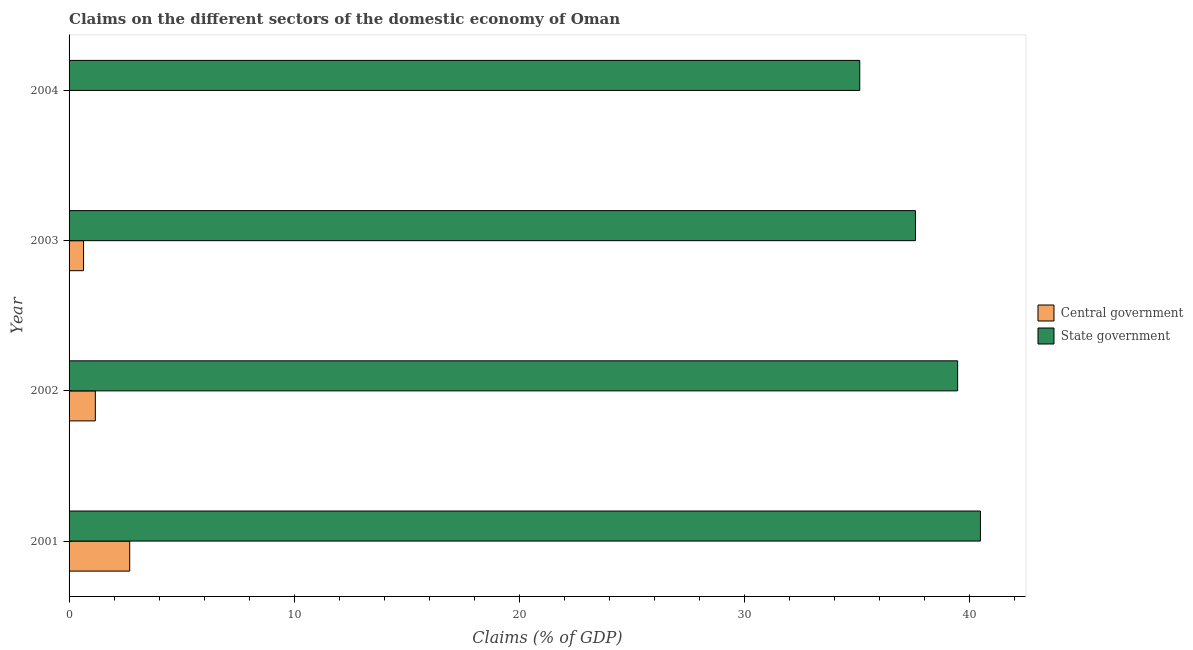How many different coloured bars are there?
Ensure brevity in your answer.  2. How many bars are there on the 2nd tick from the bottom?
Ensure brevity in your answer.  2. What is the label of the 2nd group of bars from the top?
Your answer should be very brief. 2003. In how many cases, is the number of bars for a given year not equal to the number of legend labels?
Your answer should be compact. 1. What is the claims on state government in 2001?
Provide a short and direct response. 40.51. Across all years, what is the maximum claims on state government?
Your answer should be compact. 40.51. Across all years, what is the minimum claims on state government?
Your response must be concise. 35.14. What is the total claims on central government in the graph?
Provide a short and direct response. 4.51. What is the difference between the claims on state government in 2001 and that in 2002?
Make the answer very short. 1.01. What is the difference between the claims on state government in 2002 and the claims on central government in 2001?
Make the answer very short. 36.8. What is the average claims on central government per year?
Your response must be concise. 1.13. In the year 2003, what is the difference between the claims on state government and claims on central government?
Make the answer very short. 36.97. What is the ratio of the claims on state government in 2001 to that in 2003?
Your answer should be compact. 1.08. Is the claims on central government in 2001 less than that in 2003?
Keep it short and to the point. No. What is the difference between the highest and the second highest claims on central government?
Your answer should be compact. 1.53. What is the difference between the highest and the lowest claims on central government?
Offer a terse response. 2.7. In how many years, is the claims on central government greater than the average claims on central government taken over all years?
Give a very brief answer. 2. What is the difference between two consecutive major ticks on the X-axis?
Keep it short and to the point. 10. Does the graph contain grids?
Make the answer very short. No. What is the title of the graph?
Your response must be concise. Claims on the different sectors of the domestic economy of Oman. Does "Mineral" appear as one of the legend labels in the graph?
Keep it short and to the point. No. What is the label or title of the X-axis?
Offer a terse response. Claims (% of GDP). What is the Claims (% of GDP) in Central government in 2001?
Your answer should be compact. 2.7. What is the Claims (% of GDP) in State government in 2001?
Your answer should be very brief. 40.51. What is the Claims (% of GDP) of Central government in 2002?
Provide a succinct answer. 1.17. What is the Claims (% of GDP) of State government in 2002?
Make the answer very short. 39.49. What is the Claims (% of GDP) in Central government in 2003?
Ensure brevity in your answer.  0.64. What is the Claims (% of GDP) of State government in 2003?
Give a very brief answer. 37.62. What is the Claims (% of GDP) of State government in 2004?
Your answer should be compact. 35.14. Across all years, what is the maximum Claims (% of GDP) of Central government?
Make the answer very short. 2.7. Across all years, what is the maximum Claims (% of GDP) in State government?
Provide a succinct answer. 40.51. Across all years, what is the minimum Claims (% of GDP) in Central government?
Provide a succinct answer. 0. Across all years, what is the minimum Claims (% of GDP) of State government?
Provide a succinct answer. 35.14. What is the total Claims (% of GDP) in Central government in the graph?
Keep it short and to the point. 4.51. What is the total Claims (% of GDP) of State government in the graph?
Offer a terse response. 152.76. What is the difference between the Claims (% of GDP) in Central government in 2001 and that in 2002?
Your answer should be very brief. 1.53. What is the difference between the Claims (% of GDP) in State government in 2001 and that in 2002?
Offer a very short reply. 1.01. What is the difference between the Claims (% of GDP) of Central government in 2001 and that in 2003?
Provide a succinct answer. 2.05. What is the difference between the Claims (% of GDP) in State government in 2001 and that in 2003?
Your answer should be compact. 2.89. What is the difference between the Claims (% of GDP) of State government in 2001 and that in 2004?
Offer a very short reply. 5.36. What is the difference between the Claims (% of GDP) in Central government in 2002 and that in 2003?
Give a very brief answer. 0.52. What is the difference between the Claims (% of GDP) of State government in 2002 and that in 2003?
Your response must be concise. 1.88. What is the difference between the Claims (% of GDP) in State government in 2002 and that in 2004?
Make the answer very short. 4.35. What is the difference between the Claims (% of GDP) in State government in 2003 and that in 2004?
Offer a terse response. 2.48. What is the difference between the Claims (% of GDP) of Central government in 2001 and the Claims (% of GDP) of State government in 2002?
Make the answer very short. -36.8. What is the difference between the Claims (% of GDP) in Central government in 2001 and the Claims (% of GDP) in State government in 2003?
Make the answer very short. -34.92. What is the difference between the Claims (% of GDP) of Central government in 2001 and the Claims (% of GDP) of State government in 2004?
Offer a very short reply. -32.45. What is the difference between the Claims (% of GDP) of Central government in 2002 and the Claims (% of GDP) of State government in 2003?
Provide a succinct answer. -36.45. What is the difference between the Claims (% of GDP) in Central government in 2002 and the Claims (% of GDP) in State government in 2004?
Offer a very short reply. -33.98. What is the difference between the Claims (% of GDP) in Central government in 2003 and the Claims (% of GDP) in State government in 2004?
Your answer should be compact. -34.5. What is the average Claims (% of GDP) of Central government per year?
Provide a short and direct response. 1.13. What is the average Claims (% of GDP) in State government per year?
Provide a short and direct response. 38.19. In the year 2001, what is the difference between the Claims (% of GDP) of Central government and Claims (% of GDP) of State government?
Provide a succinct answer. -37.81. In the year 2002, what is the difference between the Claims (% of GDP) in Central government and Claims (% of GDP) in State government?
Provide a short and direct response. -38.33. In the year 2003, what is the difference between the Claims (% of GDP) in Central government and Claims (% of GDP) in State government?
Provide a short and direct response. -36.97. What is the ratio of the Claims (% of GDP) of Central government in 2001 to that in 2002?
Make the answer very short. 2.31. What is the ratio of the Claims (% of GDP) of State government in 2001 to that in 2002?
Ensure brevity in your answer.  1.03. What is the ratio of the Claims (% of GDP) of Central government in 2001 to that in 2003?
Provide a succinct answer. 4.19. What is the ratio of the Claims (% of GDP) of State government in 2001 to that in 2003?
Offer a very short reply. 1.08. What is the ratio of the Claims (% of GDP) of State government in 2001 to that in 2004?
Give a very brief answer. 1.15. What is the ratio of the Claims (% of GDP) in Central government in 2002 to that in 2003?
Give a very brief answer. 1.81. What is the ratio of the Claims (% of GDP) of State government in 2002 to that in 2003?
Make the answer very short. 1.05. What is the ratio of the Claims (% of GDP) in State government in 2002 to that in 2004?
Provide a short and direct response. 1.12. What is the ratio of the Claims (% of GDP) of State government in 2003 to that in 2004?
Your answer should be very brief. 1.07. What is the difference between the highest and the second highest Claims (% of GDP) of Central government?
Your answer should be compact. 1.53. What is the difference between the highest and the second highest Claims (% of GDP) in State government?
Provide a succinct answer. 1.01. What is the difference between the highest and the lowest Claims (% of GDP) in Central government?
Offer a very short reply. 2.7. What is the difference between the highest and the lowest Claims (% of GDP) of State government?
Provide a succinct answer. 5.36. 